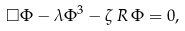<formula> <loc_0><loc_0><loc_500><loc_500>\Box \Phi - \lambda \Phi ^ { 3 } - \zeta \, R \, \Phi = 0 ,</formula> 